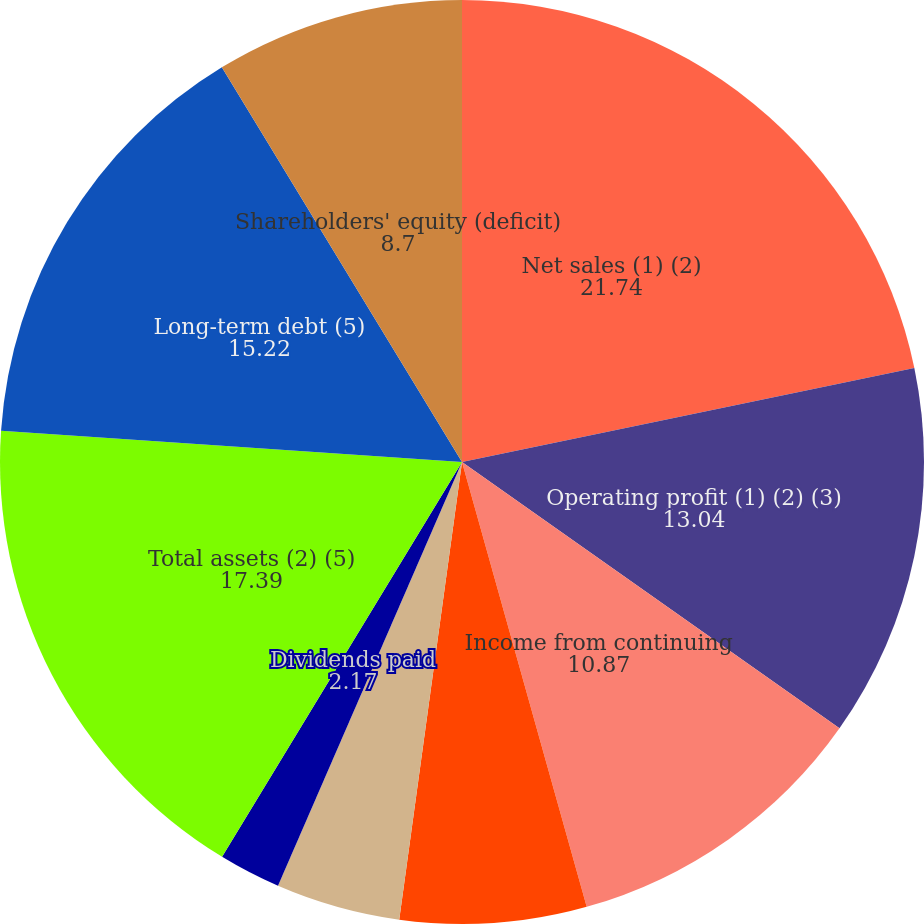Convert chart. <chart><loc_0><loc_0><loc_500><loc_500><pie_chart><fcel>Net sales (1) (2)<fcel>Operating profit (1) (2) (3)<fcel>Income from continuing<fcel>Basic<fcel>Diluted<fcel>Dividends declared<fcel>Dividends paid<fcel>Total assets (2) (5)<fcel>Long-term debt (5)<fcel>Shareholders' equity (deficit)<nl><fcel>21.74%<fcel>13.04%<fcel>10.87%<fcel>6.52%<fcel>4.35%<fcel>0.0%<fcel>2.17%<fcel>17.39%<fcel>15.22%<fcel>8.7%<nl></chart> 